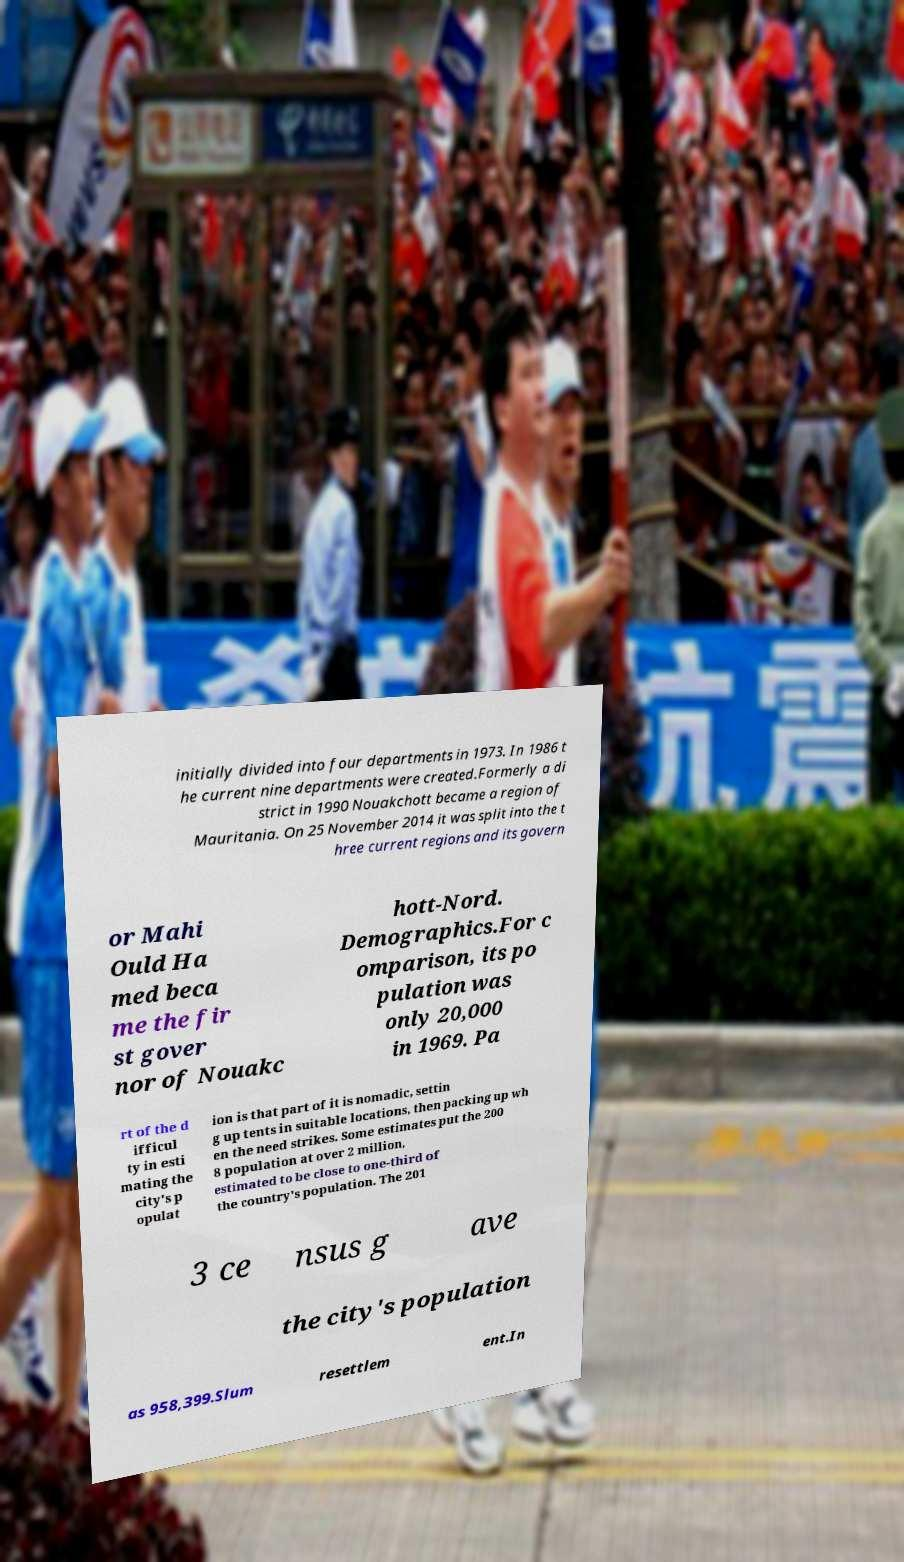Can you read and provide the text displayed in the image?This photo seems to have some interesting text. Can you extract and type it out for me? initially divided into four departments in 1973. In 1986 t he current nine departments were created.Formerly a di strict in 1990 Nouakchott became a region of Mauritania. On 25 November 2014 it was split into the t hree current regions and its govern or Mahi Ould Ha med beca me the fir st gover nor of Nouakc hott-Nord. Demographics.For c omparison, its po pulation was only 20,000 in 1969. Pa rt of the d ifficul ty in esti mating the city's p opulat ion is that part of it is nomadic, settin g up tents in suitable locations, then packing up wh en the need strikes. Some estimates put the 200 8 population at over 2 million, estimated to be close to one-third of the country's population. The 201 3 ce nsus g ave the city's population as 958,399.Slum resettlem ent.In 